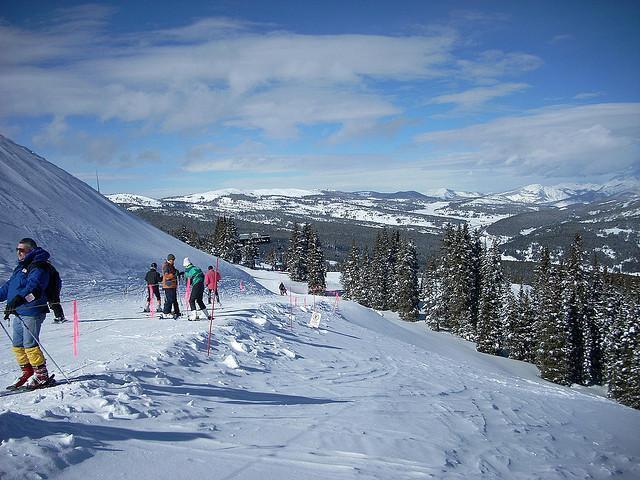Why are pink ribbons tied on the string?
Select the accurate answer and provide explanation: 'Answer: answer
Rationale: rationale.'
Options: Cancer awareness, wind direction, girl's night, visibility safety. Answer: visibility safety.
Rationale: Pink is an easy color to see in the snow. 